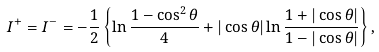Convert formula to latex. <formula><loc_0><loc_0><loc_500><loc_500>I ^ { + } = I ^ { - } = - \frac { 1 } { 2 } \left \{ \ln \frac { 1 - \cos ^ { 2 } \theta } { 4 } + | \cos \theta | \ln \frac { 1 + | \cos \theta | } { 1 - | \cos \theta | } \right \} ,</formula> 